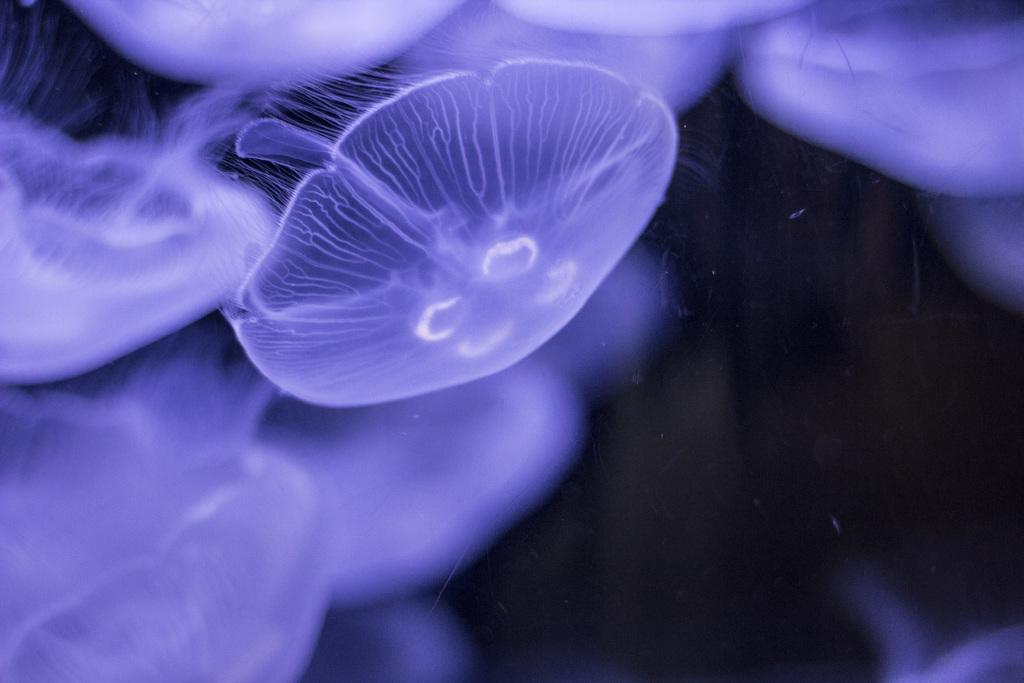Could you give a brief overview of what you see in this image? In this image we can see some jellyfish, and the background is dark. 